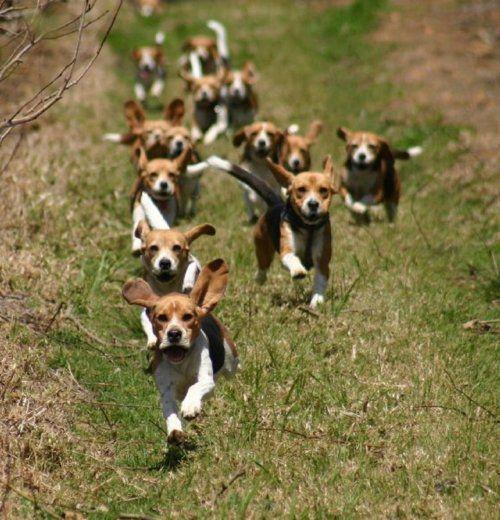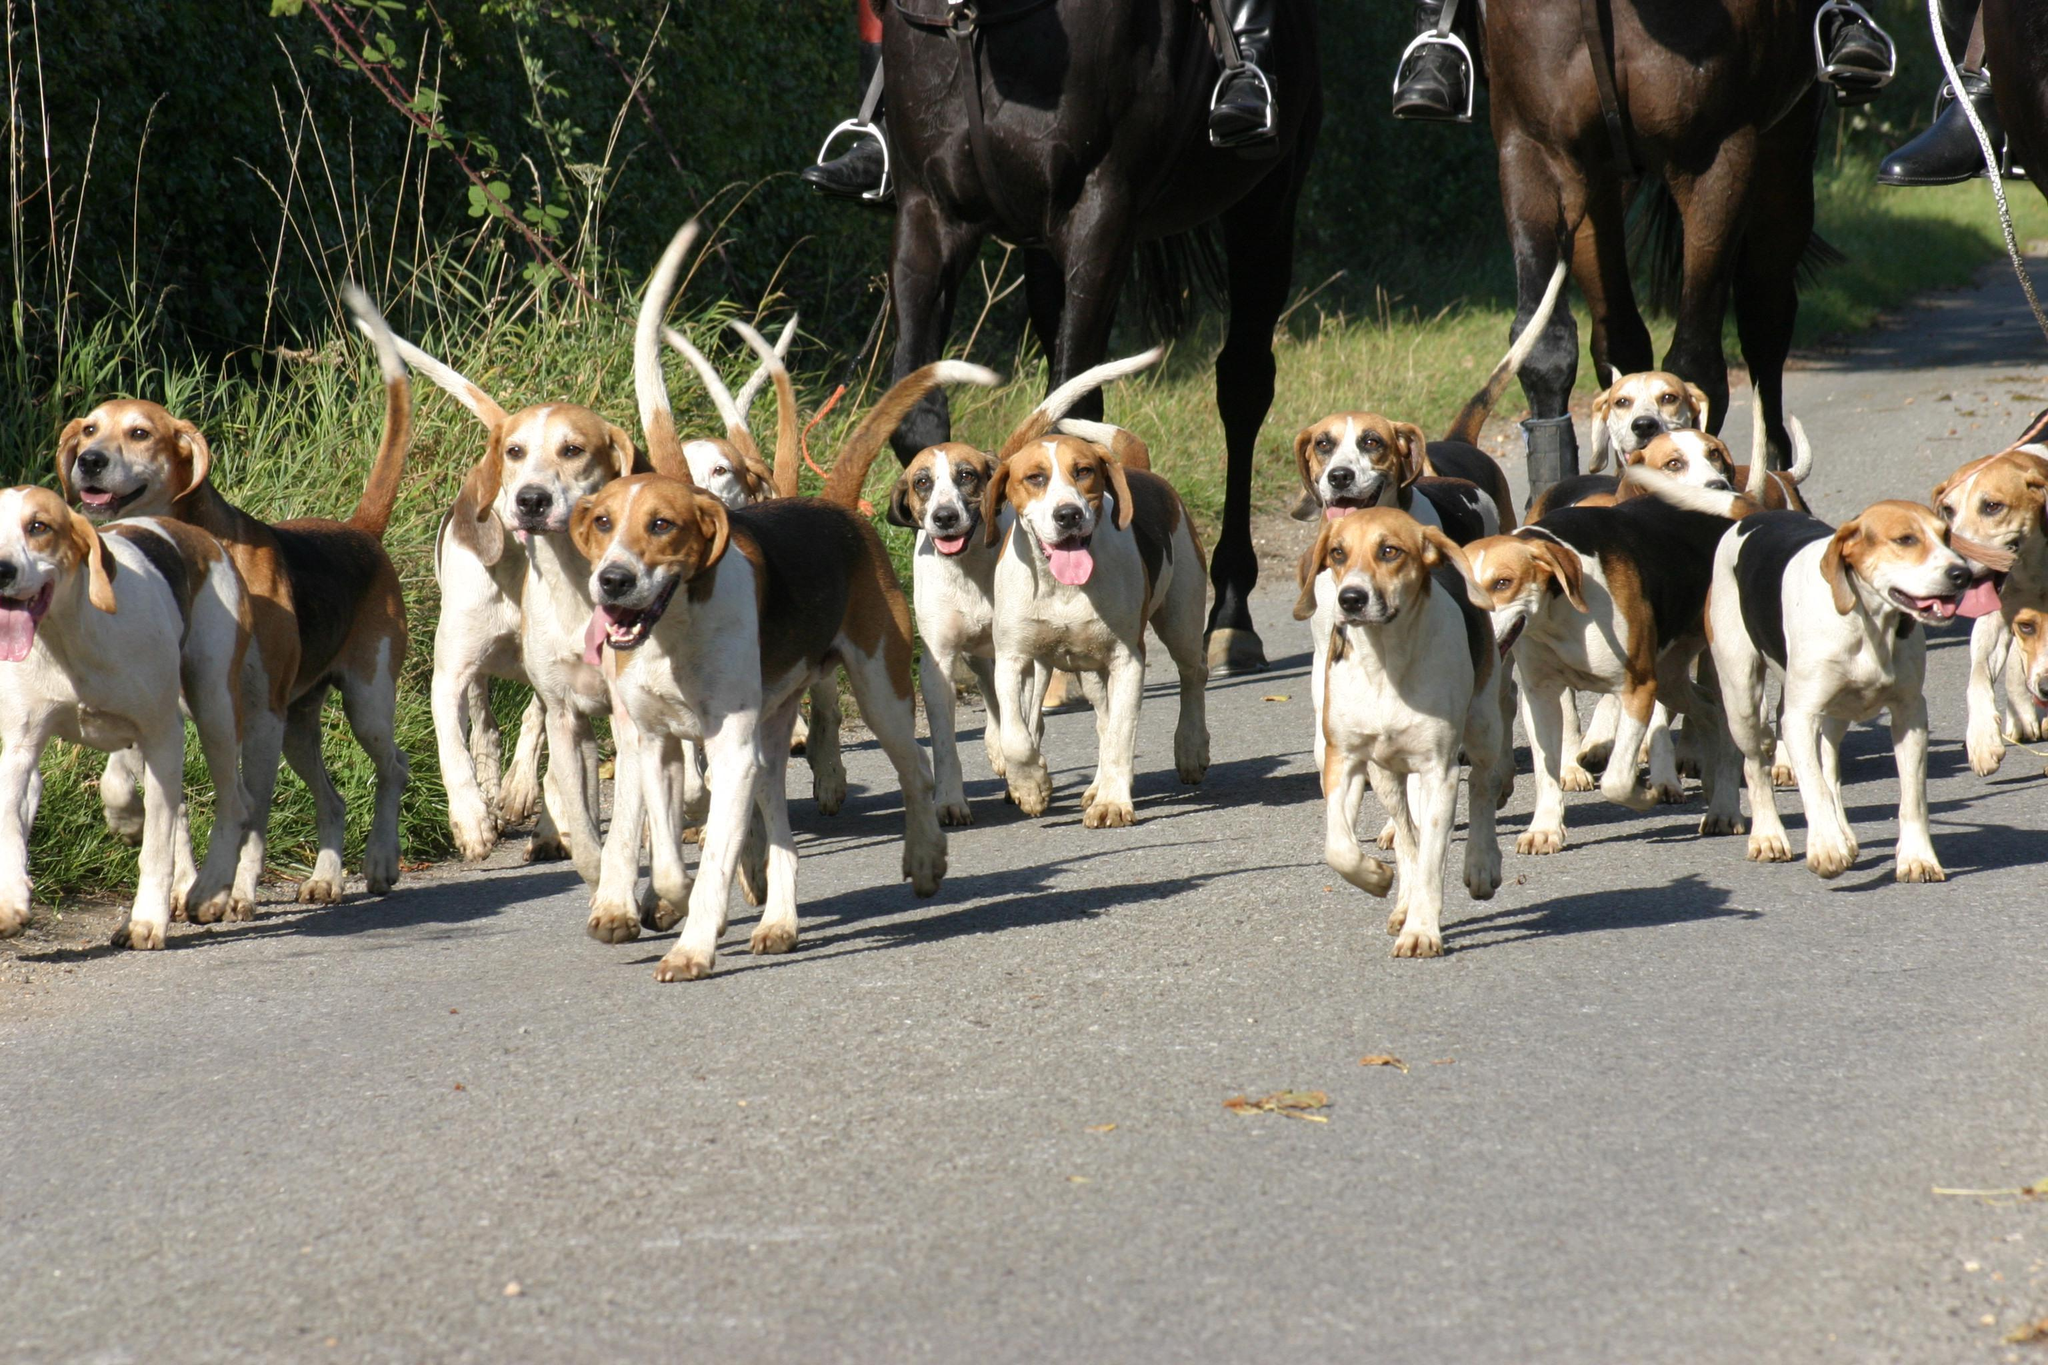The first image is the image on the left, the second image is the image on the right. Examine the images to the left and right. Is the description "There are exactly two people in the image on the right." accurate? Answer yes or no. No. 